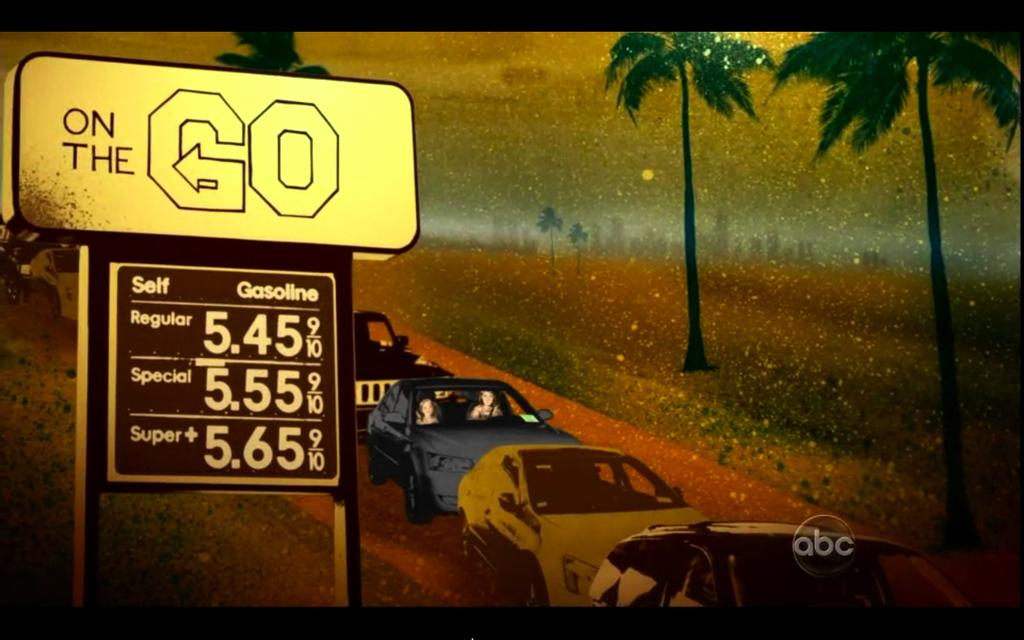What is the main subject of the image? The main subject of the image is a poster. What types of images are on the poster? The poster contains images of cars and trees. What other elements are present on the poster? There is text and numbers on the poster. How is the poster related to the board in the image? The poster appears to be a graphical representation of a board. Where is the board located in the image? The board is on the left side of the picture. Can you tell me how many faucets are visible in the image? There are no faucets present in the image; it features a poster with images of cars and trees, as well as text and numbers. What channel is the board on in the image? The image is a still picture and does not depict a channel or any form of broadcasting. 